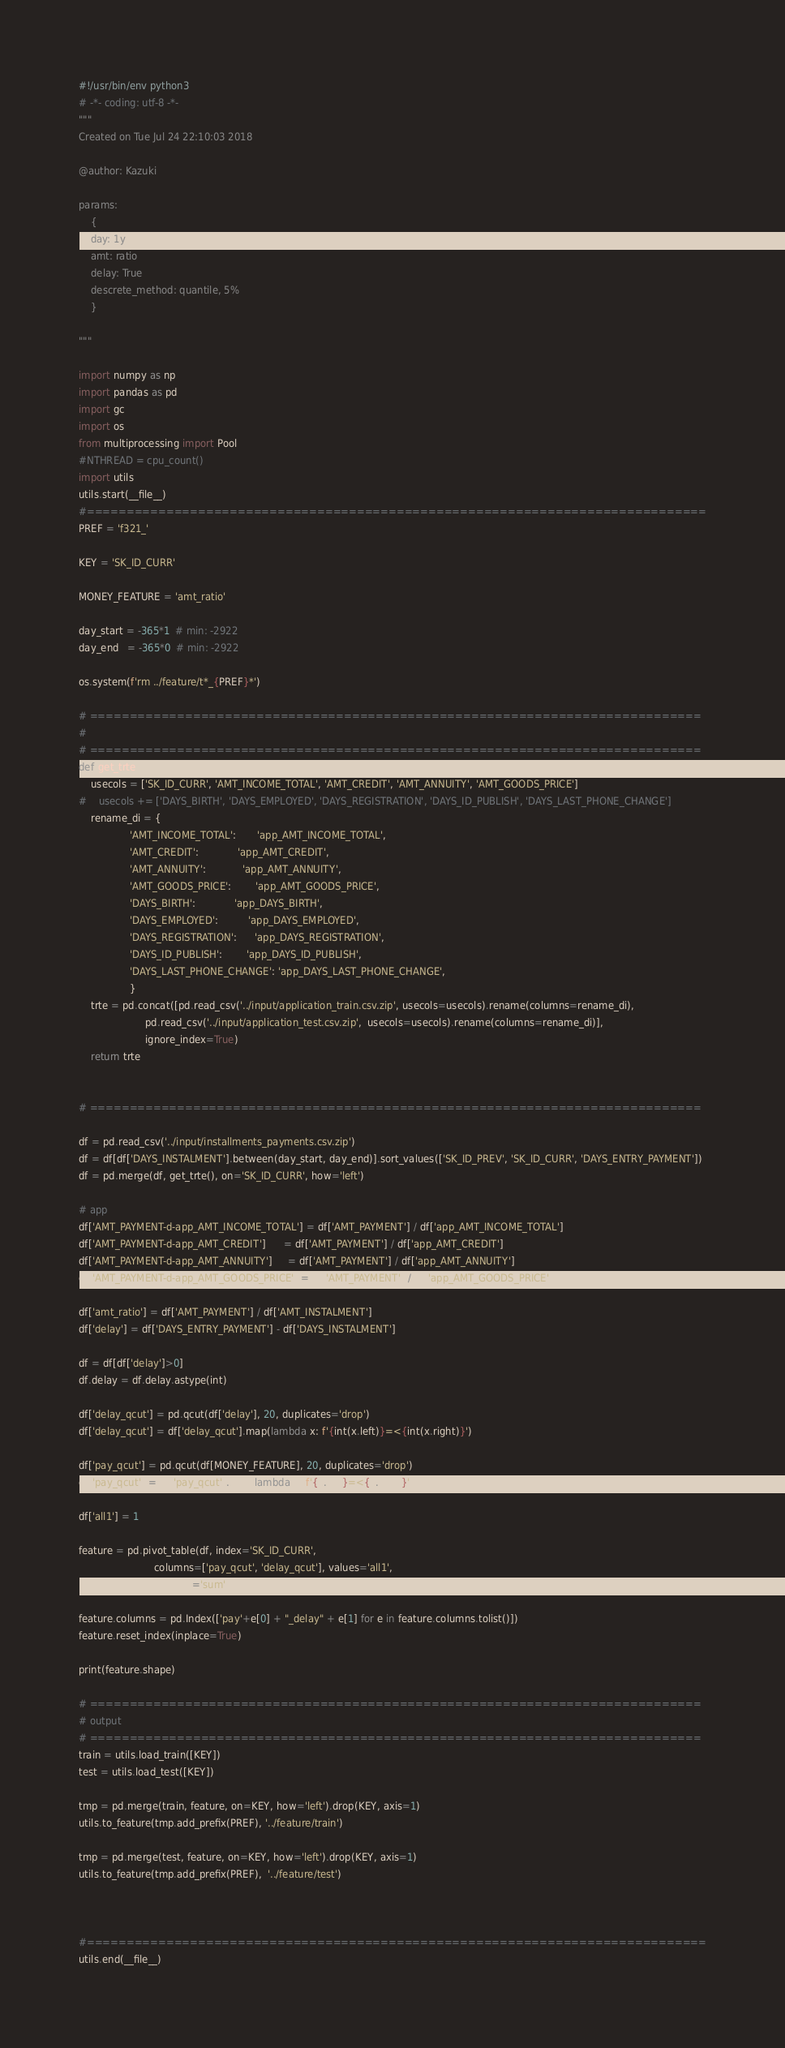Convert code to text. <code><loc_0><loc_0><loc_500><loc_500><_Python_>#!/usr/bin/env python3
# -*- coding: utf-8 -*-
"""
Created on Tue Jul 24 22:10:03 2018

@author: Kazuki

params:
    {
    day: 1y
    amt: ratio
    delay: True
    descrete_method: quantile, 5%
    }

"""

import numpy as np
import pandas as pd
import gc
import os
from multiprocessing import Pool
#NTHREAD = cpu_count()
import utils
utils.start(__file__)
#==============================================================================
PREF = 'f321_'

KEY = 'SK_ID_CURR'

MONEY_FEATURE = 'amt_ratio'

day_start = -365*1  # min: -2922
day_end   = -365*0  # min: -2922

os.system(f'rm ../feature/t*_{PREF}*')

# =============================================================================
# 
# =============================================================================
def get_trte():
    usecols = ['SK_ID_CURR', 'AMT_INCOME_TOTAL', 'AMT_CREDIT', 'AMT_ANNUITY', 'AMT_GOODS_PRICE']
#    usecols += ['DAYS_BIRTH', 'DAYS_EMPLOYED', 'DAYS_REGISTRATION', 'DAYS_ID_PUBLISH', 'DAYS_LAST_PHONE_CHANGE']
    rename_di = {
                 'AMT_INCOME_TOTAL':       'app_AMT_INCOME_TOTAL', 
                 'AMT_CREDIT':             'app_AMT_CREDIT', 
                 'AMT_ANNUITY':            'app_AMT_ANNUITY',
                 'AMT_GOODS_PRICE':        'app_AMT_GOODS_PRICE',
                 'DAYS_BIRTH':             'app_DAYS_BIRTH', 
                 'DAYS_EMPLOYED':          'app_DAYS_EMPLOYED', 
                 'DAYS_REGISTRATION':      'app_DAYS_REGISTRATION', 
                 'DAYS_ID_PUBLISH':        'app_DAYS_ID_PUBLISH', 
                 'DAYS_LAST_PHONE_CHANGE': 'app_DAYS_LAST_PHONE_CHANGE',
                 }
    trte = pd.concat([pd.read_csv('../input/application_train.csv.zip', usecols=usecols).rename(columns=rename_di), 
                      pd.read_csv('../input/application_test.csv.zip',  usecols=usecols).rename(columns=rename_di)],
                      ignore_index=True)
    return trte


# =============================================================================

df = pd.read_csv('../input/installments_payments.csv.zip')
df = df[df['DAYS_INSTALMENT'].between(day_start, day_end)].sort_values(['SK_ID_PREV', 'SK_ID_CURR', 'DAYS_ENTRY_PAYMENT'])
df = pd.merge(df, get_trte(), on='SK_ID_CURR', how='left')

# app
df['AMT_PAYMENT-d-app_AMT_INCOME_TOTAL'] = df['AMT_PAYMENT'] / df['app_AMT_INCOME_TOTAL']
df['AMT_PAYMENT-d-app_AMT_CREDIT']      = df['AMT_PAYMENT'] / df['app_AMT_CREDIT']
df['AMT_PAYMENT-d-app_AMT_ANNUITY']     = df['AMT_PAYMENT'] / df['app_AMT_ANNUITY']
df['AMT_PAYMENT-d-app_AMT_GOODS_PRICE'] = df['AMT_PAYMENT'] / df['app_AMT_GOODS_PRICE']

df['amt_ratio'] = df['AMT_PAYMENT'] / df['AMT_INSTALMENT']
df['delay'] = df['DAYS_ENTRY_PAYMENT'] - df['DAYS_INSTALMENT']

df = df[df['delay']>0]
df.delay = df.delay.astype(int)

df['delay_qcut'] = pd.qcut(df['delay'], 20, duplicates='drop')
df['delay_qcut'] = df['delay_qcut'].map(lambda x: f'{int(x.left)}=<{int(x.right)}')

df['pay_qcut'] = pd.qcut(df[MONEY_FEATURE], 20, duplicates='drop')
df['pay_qcut'] = df['pay_qcut'].map(lambda x: f'{x.left}=<{x.right}')

df['all1'] = 1

feature = pd.pivot_table(df, index='SK_ID_CURR', 
                         columns=['pay_qcut', 'delay_qcut'], values='all1',
                         aggfunc='sum')

feature.columns = pd.Index(['pay'+e[0] + "_delay" + e[1] for e in feature.columns.tolist()])
feature.reset_index(inplace=True)

print(feature.shape)

# =============================================================================
# output
# =============================================================================
train = utils.load_train([KEY])
test = utils.load_test([KEY])

tmp = pd.merge(train, feature, on=KEY, how='left').drop(KEY, axis=1)
utils.to_feature(tmp.add_prefix(PREF), '../feature/train')

tmp = pd.merge(test, feature, on=KEY, how='left').drop(KEY, axis=1)
utils.to_feature(tmp.add_prefix(PREF),  '../feature/test')



#==============================================================================
utils.end(__file__)


</code> 